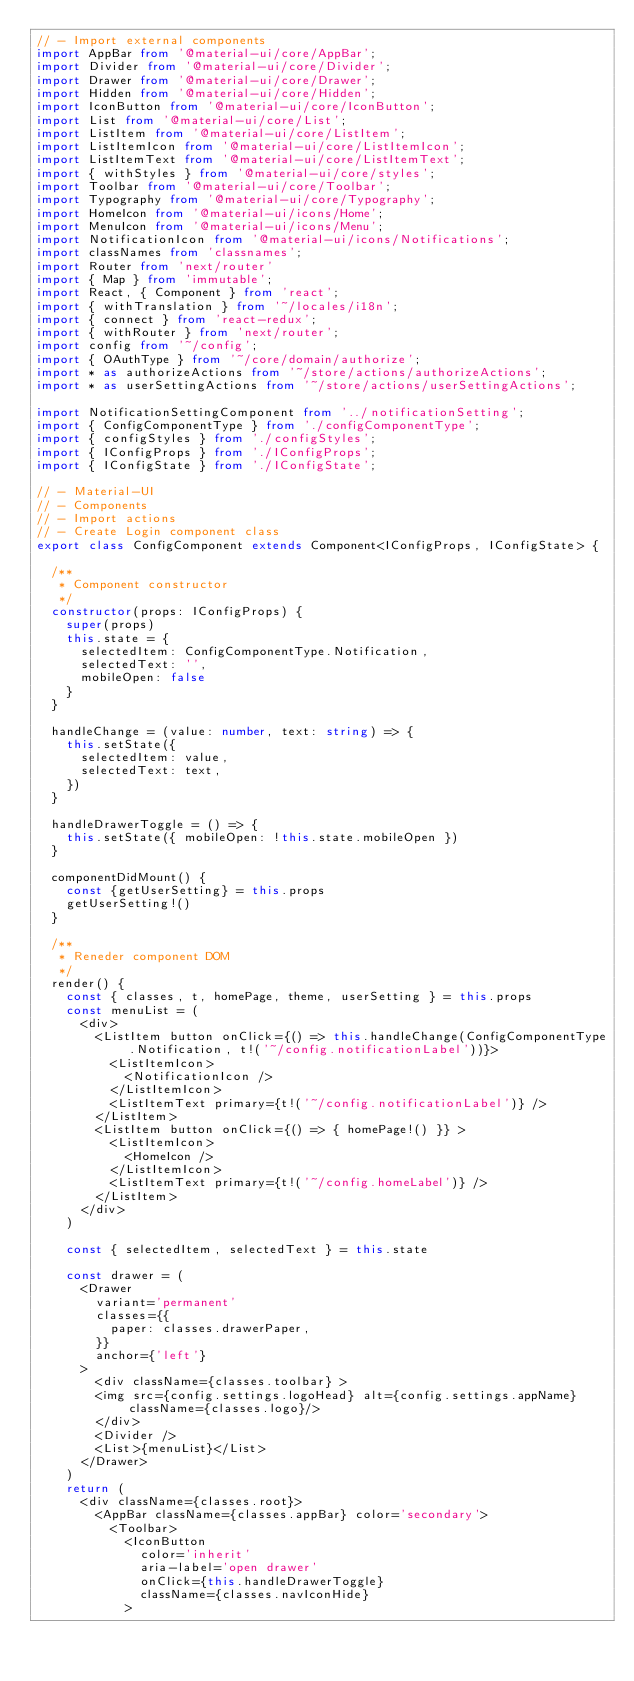<code> <loc_0><loc_0><loc_500><loc_500><_TypeScript_>// - Import external components
import AppBar from '@material-ui/core/AppBar';
import Divider from '@material-ui/core/Divider';
import Drawer from '@material-ui/core/Drawer';
import Hidden from '@material-ui/core/Hidden';
import IconButton from '@material-ui/core/IconButton';
import List from '@material-ui/core/List';
import ListItem from '@material-ui/core/ListItem';
import ListItemIcon from '@material-ui/core/ListItemIcon';
import ListItemText from '@material-ui/core/ListItemText';
import { withStyles } from '@material-ui/core/styles';
import Toolbar from '@material-ui/core/Toolbar';
import Typography from '@material-ui/core/Typography';
import HomeIcon from '@material-ui/icons/Home';
import MenuIcon from '@material-ui/icons/Menu';
import NotificationIcon from '@material-ui/icons/Notifications';
import classNames from 'classnames';
import Router from 'next/router'
import { Map } from 'immutable';
import React, { Component } from 'react';
import { withTranslation } from '~/locales/i18n';
import { connect } from 'react-redux';
import { withRouter } from 'next/router';
import config from '~/config';
import { OAuthType } from '~/core/domain/authorize';
import * as authorizeActions from '~/store/actions/authorizeActions';
import * as userSettingActions from '~/store/actions/userSettingActions';

import NotificationSettingComponent from '../notificationSetting';
import { ConfigComponentType } from './configComponentType';
import { configStyles } from './configStyles';
import { IConfigProps } from './IConfigProps';
import { IConfigState } from './IConfigState';

// - Material-UI
// - Components
// - Import actions
// - Create Login component class
export class ConfigComponent extends Component<IConfigProps, IConfigState> {

  /**
   * Component constructor
   */
  constructor(props: IConfigProps) {
    super(props)
    this.state = {
      selectedItem: ConfigComponentType.Notification,
      selectedText: '',
      mobileOpen: false
    }
  }

  handleChange = (value: number, text: string) => {
    this.setState({
      selectedItem: value,
      selectedText: text,
    })
  }

  handleDrawerToggle = () => {
    this.setState({ mobileOpen: !this.state.mobileOpen })
  }

  componentDidMount() {
    const {getUserSetting} = this.props
    getUserSetting!()
  }

  /**
   * Reneder component DOM
   */
  render() {
    const { classes, t, homePage, theme, userSetting } = this.props
    const menuList = (
      <div>
        <ListItem button onClick={() => this.handleChange(ConfigComponentType.Notification, t!('~/config.notificationLabel'))}>
          <ListItemIcon>
            <NotificationIcon />
          </ListItemIcon>
          <ListItemText primary={t!('~/config.notificationLabel')} />
        </ListItem>
        <ListItem button onClick={() => { homePage!() }} >
          <ListItemIcon>
            <HomeIcon />
          </ListItemIcon>
          <ListItemText primary={t!('~/config.homeLabel')} />
        </ListItem>
      </div>
    )

    const { selectedItem, selectedText } = this.state

    const drawer = (
      <Drawer
        variant='permanent'
        classes={{
          paper: classes.drawerPaper,
        }}
        anchor={'left'}
      >
        <div className={classes.toolbar} >
        <img src={config.settings.logoHead} alt={config.settings.appName} className={classes.logo}/>
        </div>
        <Divider />
        <List>{menuList}</List>
      </Drawer>
    )
    return (
      <div className={classes.root}>
        <AppBar className={classes.appBar} color='secondary'>
          <Toolbar>
            <IconButton
              color='inherit'
              aria-label='open drawer'
              onClick={this.handleDrawerToggle}
              className={classes.navIconHide}
            ></code> 